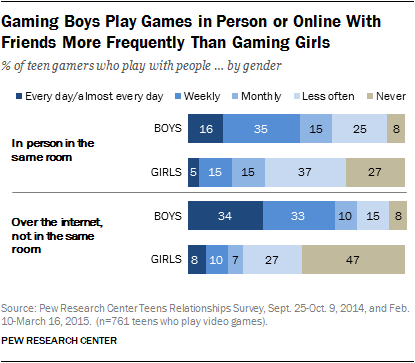Draw attention to some important aspects in this diagram. The difference between the boys who play games monthly in person in the same room and the girls who play games weekly in person in the same room is that the boys play games less frequently than the girls. According to a recent survey, only 35% of men play video games in the same physical room on a weekly basis. 